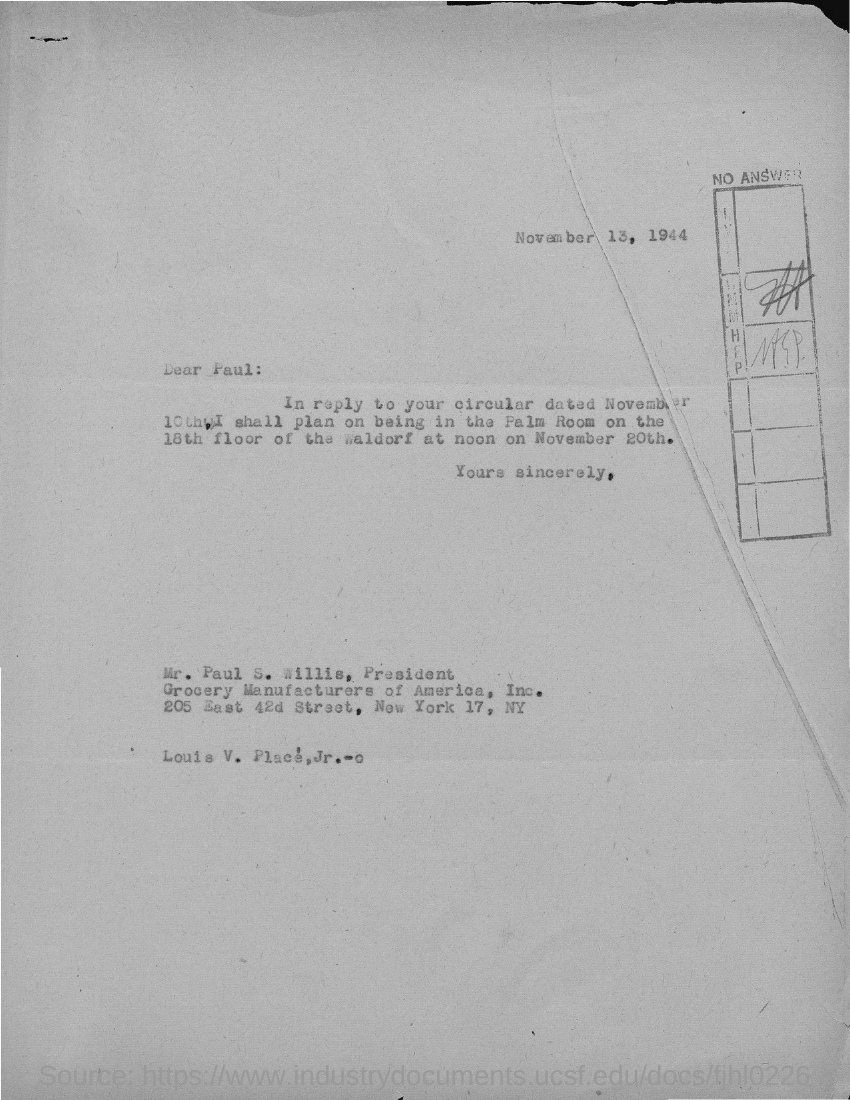What is the date mentioned at the top of the document?
Provide a succinct answer. November 13, 1944. 